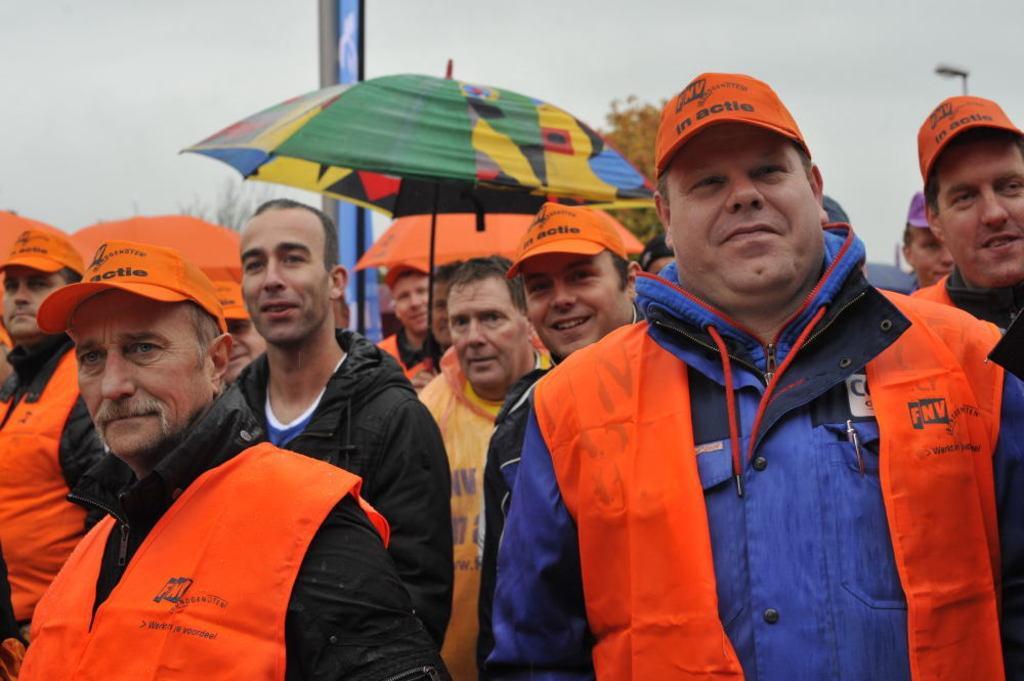Can you describe this image briefly? There are persons standing. Some of them are in orange color jackets. Some of the remaining are holding umbrellas. In the background, there are trees and there are clouds in the sky. 